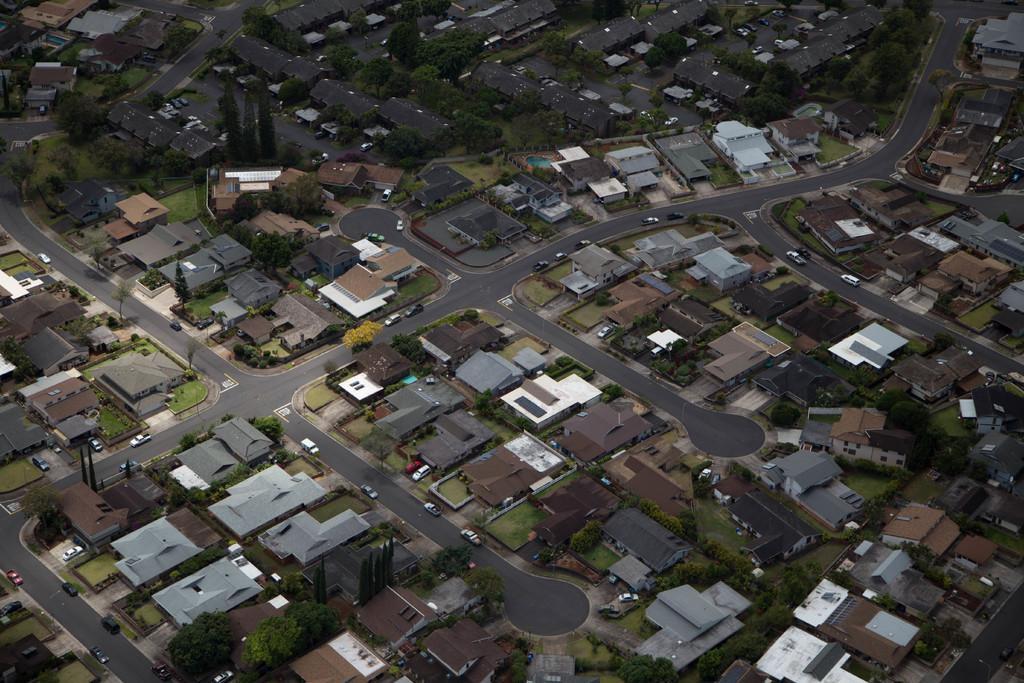In one or two sentences, can you explain what this image depicts? In this image, we can see so many houses, trees, roads and vehicles. 